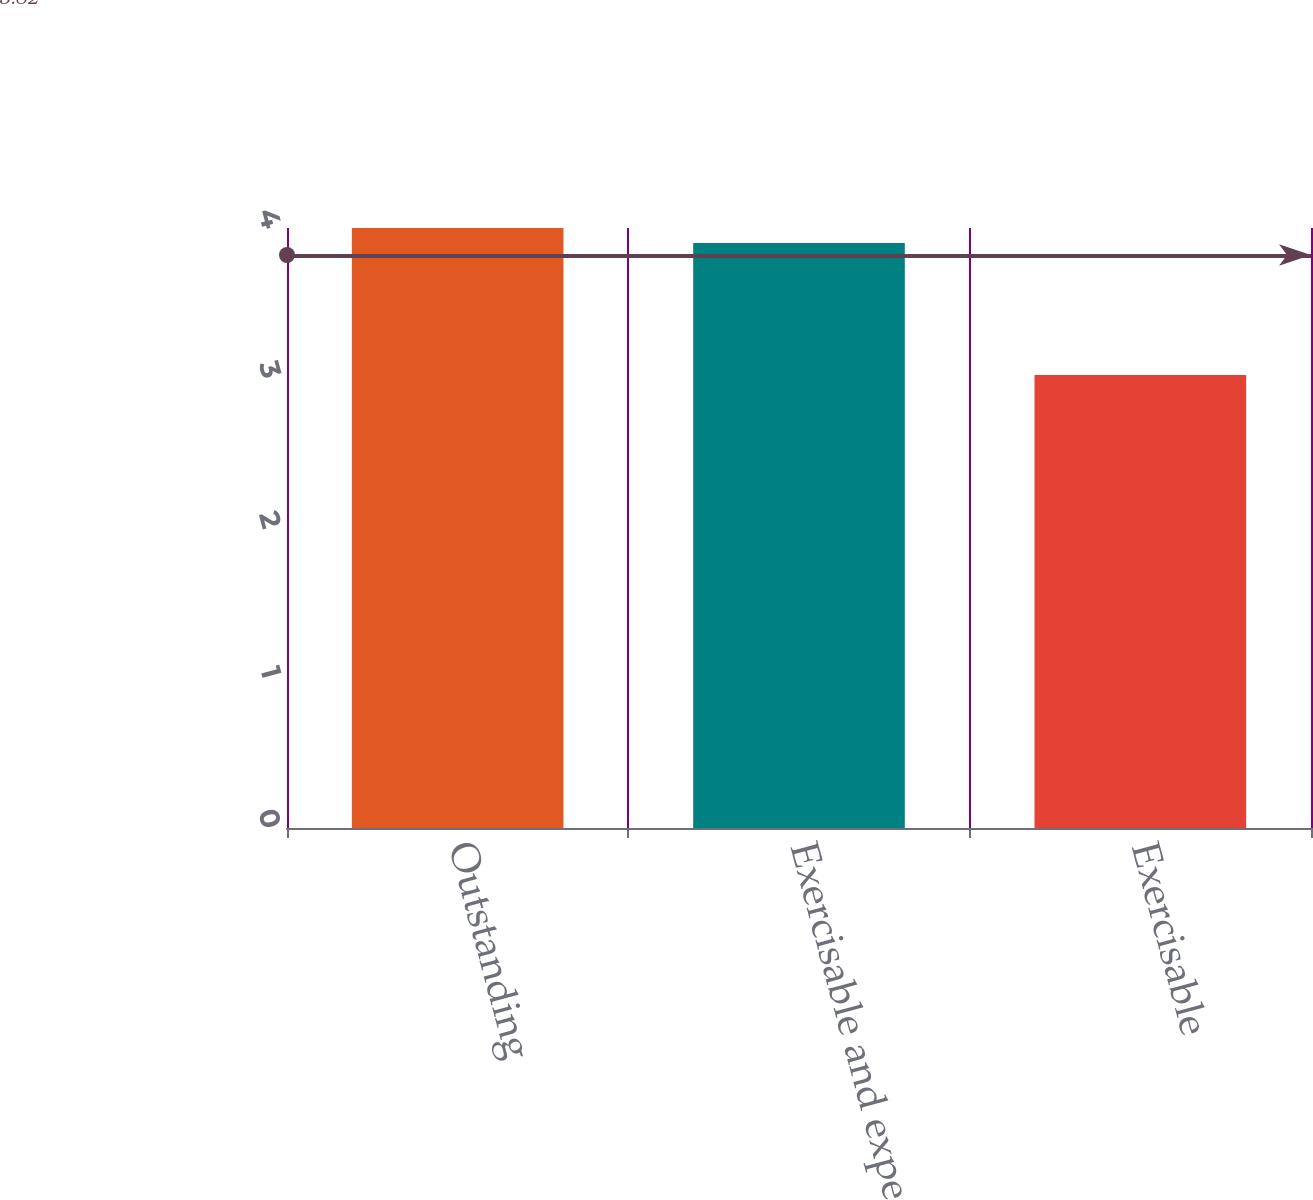Convert chart. <chart><loc_0><loc_0><loc_500><loc_500><bar_chart><fcel>Outstanding<fcel>Exercisable and expected to<fcel>Exercisable<nl><fcel>4<fcel>3.9<fcel>3.02<nl></chart> 